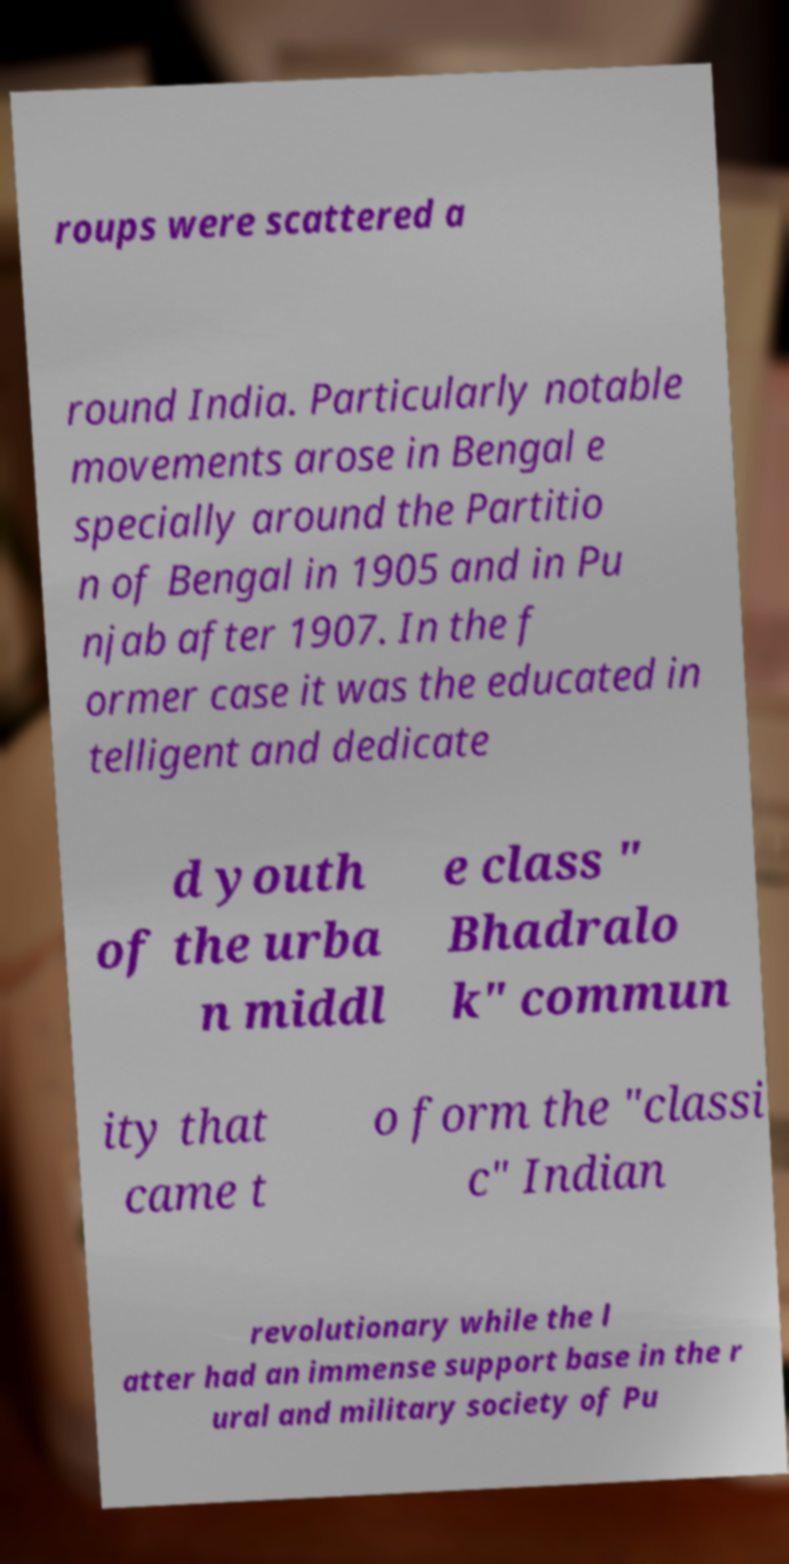For documentation purposes, I need the text within this image transcribed. Could you provide that? roups were scattered a round India. Particularly notable movements arose in Bengal e specially around the Partitio n of Bengal in 1905 and in Pu njab after 1907. In the f ormer case it was the educated in telligent and dedicate d youth of the urba n middl e class " Bhadralo k" commun ity that came t o form the "classi c" Indian revolutionary while the l atter had an immense support base in the r ural and military society of Pu 